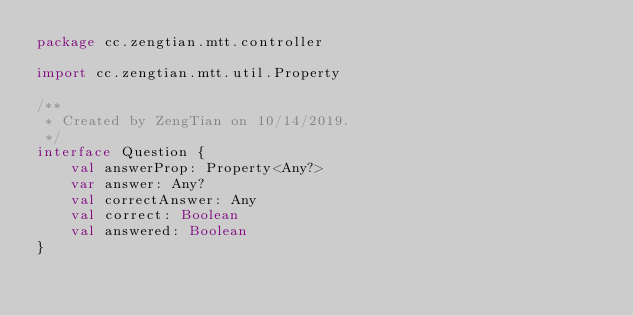<code> <loc_0><loc_0><loc_500><loc_500><_Kotlin_>package cc.zengtian.mtt.controller

import cc.zengtian.mtt.util.Property

/**
 * Created by ZengTian on 10/14/2019.
 */
interface Question {
    val answerProp: Property<Any?>
    var answer: Any?
    val correctAnswer: Any
    val correct: Boolean
    val answered: Boolean
}
</code> 